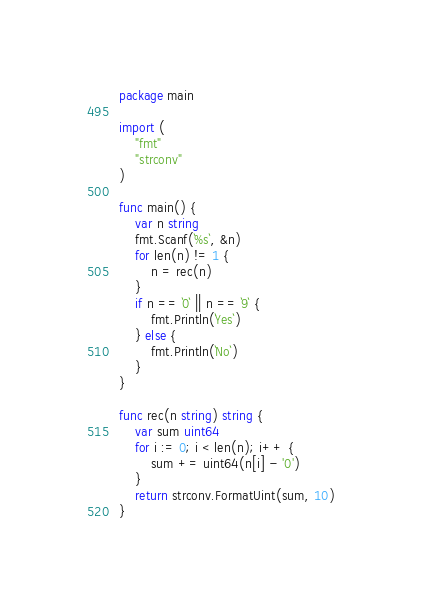<code> <loc_0><loc_0><loc_500><loc_500><_Go_>package main

import (
	"fmt"
	"strconv"
)

func main() {
	var n string
	fmt.Scanf(`%s`, &n)
	for len(n) != 1 {
		n = rec(n)
	}
	if n == `0` || n == `9` {
		fmt.Println(`Yes`)
	} else {
		fmt.Println(`No`)
	}
}

func rec(n string) string {
	var sum uint64
	for i := 0; i < len(n); i++ {
		sum += uint64(n[i] - '0')
	}
	return strconv.FormatUint(sum, 10)
}</code> 